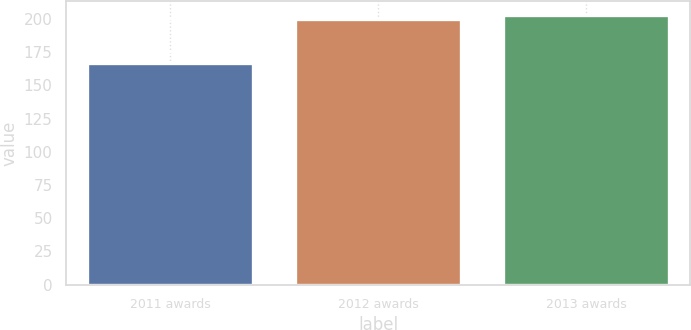Convert chart. <chart><loc_0><loc_0><loc_500><loc_500><bar_chart><fcel>2011 awards<fcel>2012 awards<fcel>2013 awards<nl><fcel>166.7<fcel>200<fcel>203.33<nl></chart> 